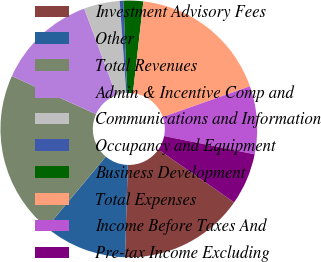Convert chart. <chart><loc_0><loc_0><loc_500><loc_500><pie_chart><fcel>Investment Advisory Fees<fcel>Other<fcel>Total Revenues<fcel>Admin & Incentive Comp and<fcel>Communications and Information<fcel>Occupancy and Equipment<fcel>Business Development<fcel>Total Expenses<fcel>Income Before Taxes And<fcel>Pre-tax Income Excluding<nl><fcel>15.78%<fcel>10.58%<fcel>20.7%<fcel>12.6%<fcel>4.51%<fcel>0.46%<fcel>2.48%<fcel>17.81%<fcel>8.55%<fcel>6.53%<nl></chart> 